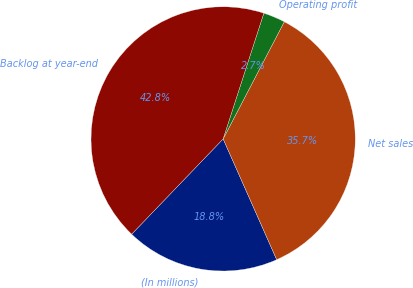Convert chart. <chart><loc_0><loc_0><loc_500><loc_500><pie_chart><fcel>(In millions)<fcel>Net sales<fcel>Operating profit<fcel>Backlog at year-end<nl><fcel>18.82%<fcel>35.7%<fcel>2.68%<fcel>42.81%<nl></chart> 